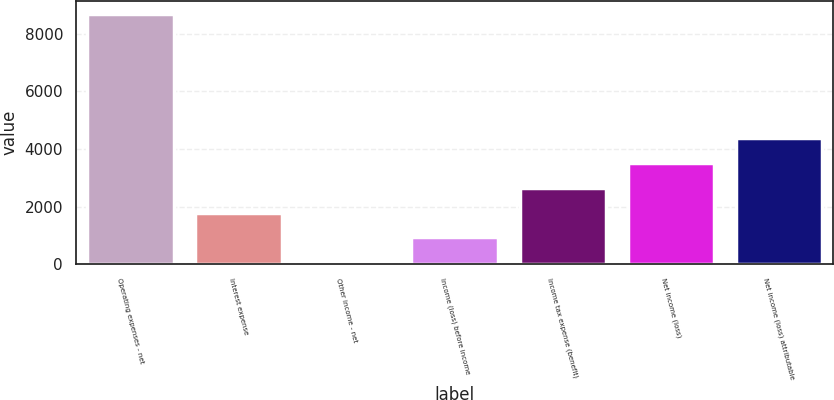Convert chart. <chart><loc_0><loc_0><loc_500><loc_500><bar_chart><fcel>Operating expenses - net<fcel>Interest expense<fcel>Other income - net<fcel>Income (loss) before income<fcel>Income tax expense (benefit)<fcel>Net income (loss)<fcel>Net income (loss) attributable<nl><fcel>8695<fcel>1795<fcel>70<fcel>932.5<fcel>2657.5<fcel>3520<fcel>4382.5<nl></chart> 